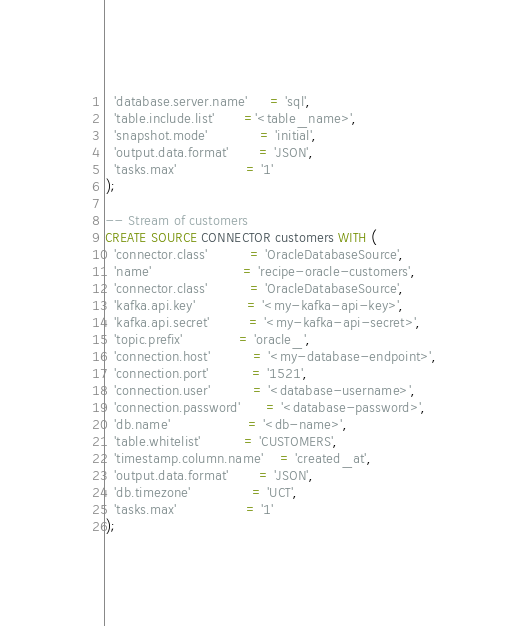<code> <loc_0><loc_0><loc_500><loc_500><_SQL_>  'database.server.name'     = 'sql',
  'table.include.list'       ='<table_name>',
  'snapshot.mode'            = 'initial',
  'output.data.format'       = 'JSON',
  'tasks.max'                = '1'
);

-- Stream of customers
CREATE SOURCE CONNECTOR customers WITH (
  'connector.class'          = 'OracleDatabaseSource',
  'name'                     = 'recipe-oracle-customers',
  'connector.class'          = 'OracleDatabaseSource',
  'kafka.api.key'            = '<my-kafka-api-key>',
  'kafka.api.secret'         = '<my-kafka-api-secret>',
  'topic.prefix'             = 'oracle_',
  'connection.host'          = '<my-database-endpoint>',
  'connection.port'          = '1521',
  'connection.user'          = '<database-username>',
  'connection.password'      = '<database-password>',
  'db.name'                  = '<db-name>',
  'table.whitelist'          = 'CUSTOMERS',
  'timestamp.column.name'    = 'created_at',
  'output.data.format'       = 'JSON',
  'db.timezone'              = 'UCT',
  'tasks.max'                = '1'
);
</code> 